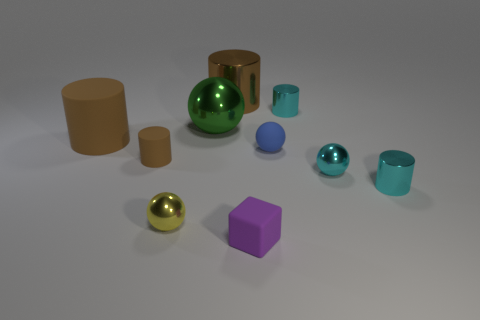Are there more brown cylinders on the left side of the large brown rubber cylinder than cyan metal balls?
Your answer should be very brief. No. How many other things are the same size as the yellow ball?
Provide a short and direct response. 6. There is a blue rubber ball; how many tiny rubber blocks are behind it?
Your answer should be compact. 0. Are there the same number of cyan things that are behind the large green ball and big brown matte cylinders that are behind the cyan shiny sphere?
Ensure brevity in your answer.  Yes. There is another brown rubber thing that is the same shape as the tiny brown matte object; what is its size?
Provide a succinct answer. Large. What is the shape of the cyan thing that is behind the tiny brown thing?
Your answer should be very brief. Cylinder. Does the ball that is behind the blue matte thing have the same material as the large cylinder that is in front of the large brown shiny thing?
Offer a very short reply. No. The purple object has what shape?
Provide a succinct answer. Cube. Are there the same number of green metal things that are in front of the small cyan metal sphere and tiny rubber spheres?
Provide a succinct answer. No. What is the size of the rubber thing that is the same color as the large rubber cylinder?
Keep it short and to the point. Small. 